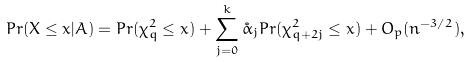<formula> <loc_0><loc_0><loc_500><loc_500>P r ( X \leq x | A ) = P r ( \chi ^ { 2 } _ { q } \leq x ) + \sum _ { j = 0 } ^ { k } \mathring { \alpha } _ { j } P r ( \chi ^ { 2 } _ { q + 2 j } \leq x ) + O _ { p } ( n ^ { - 3 / 2 } ) ,</formula> 